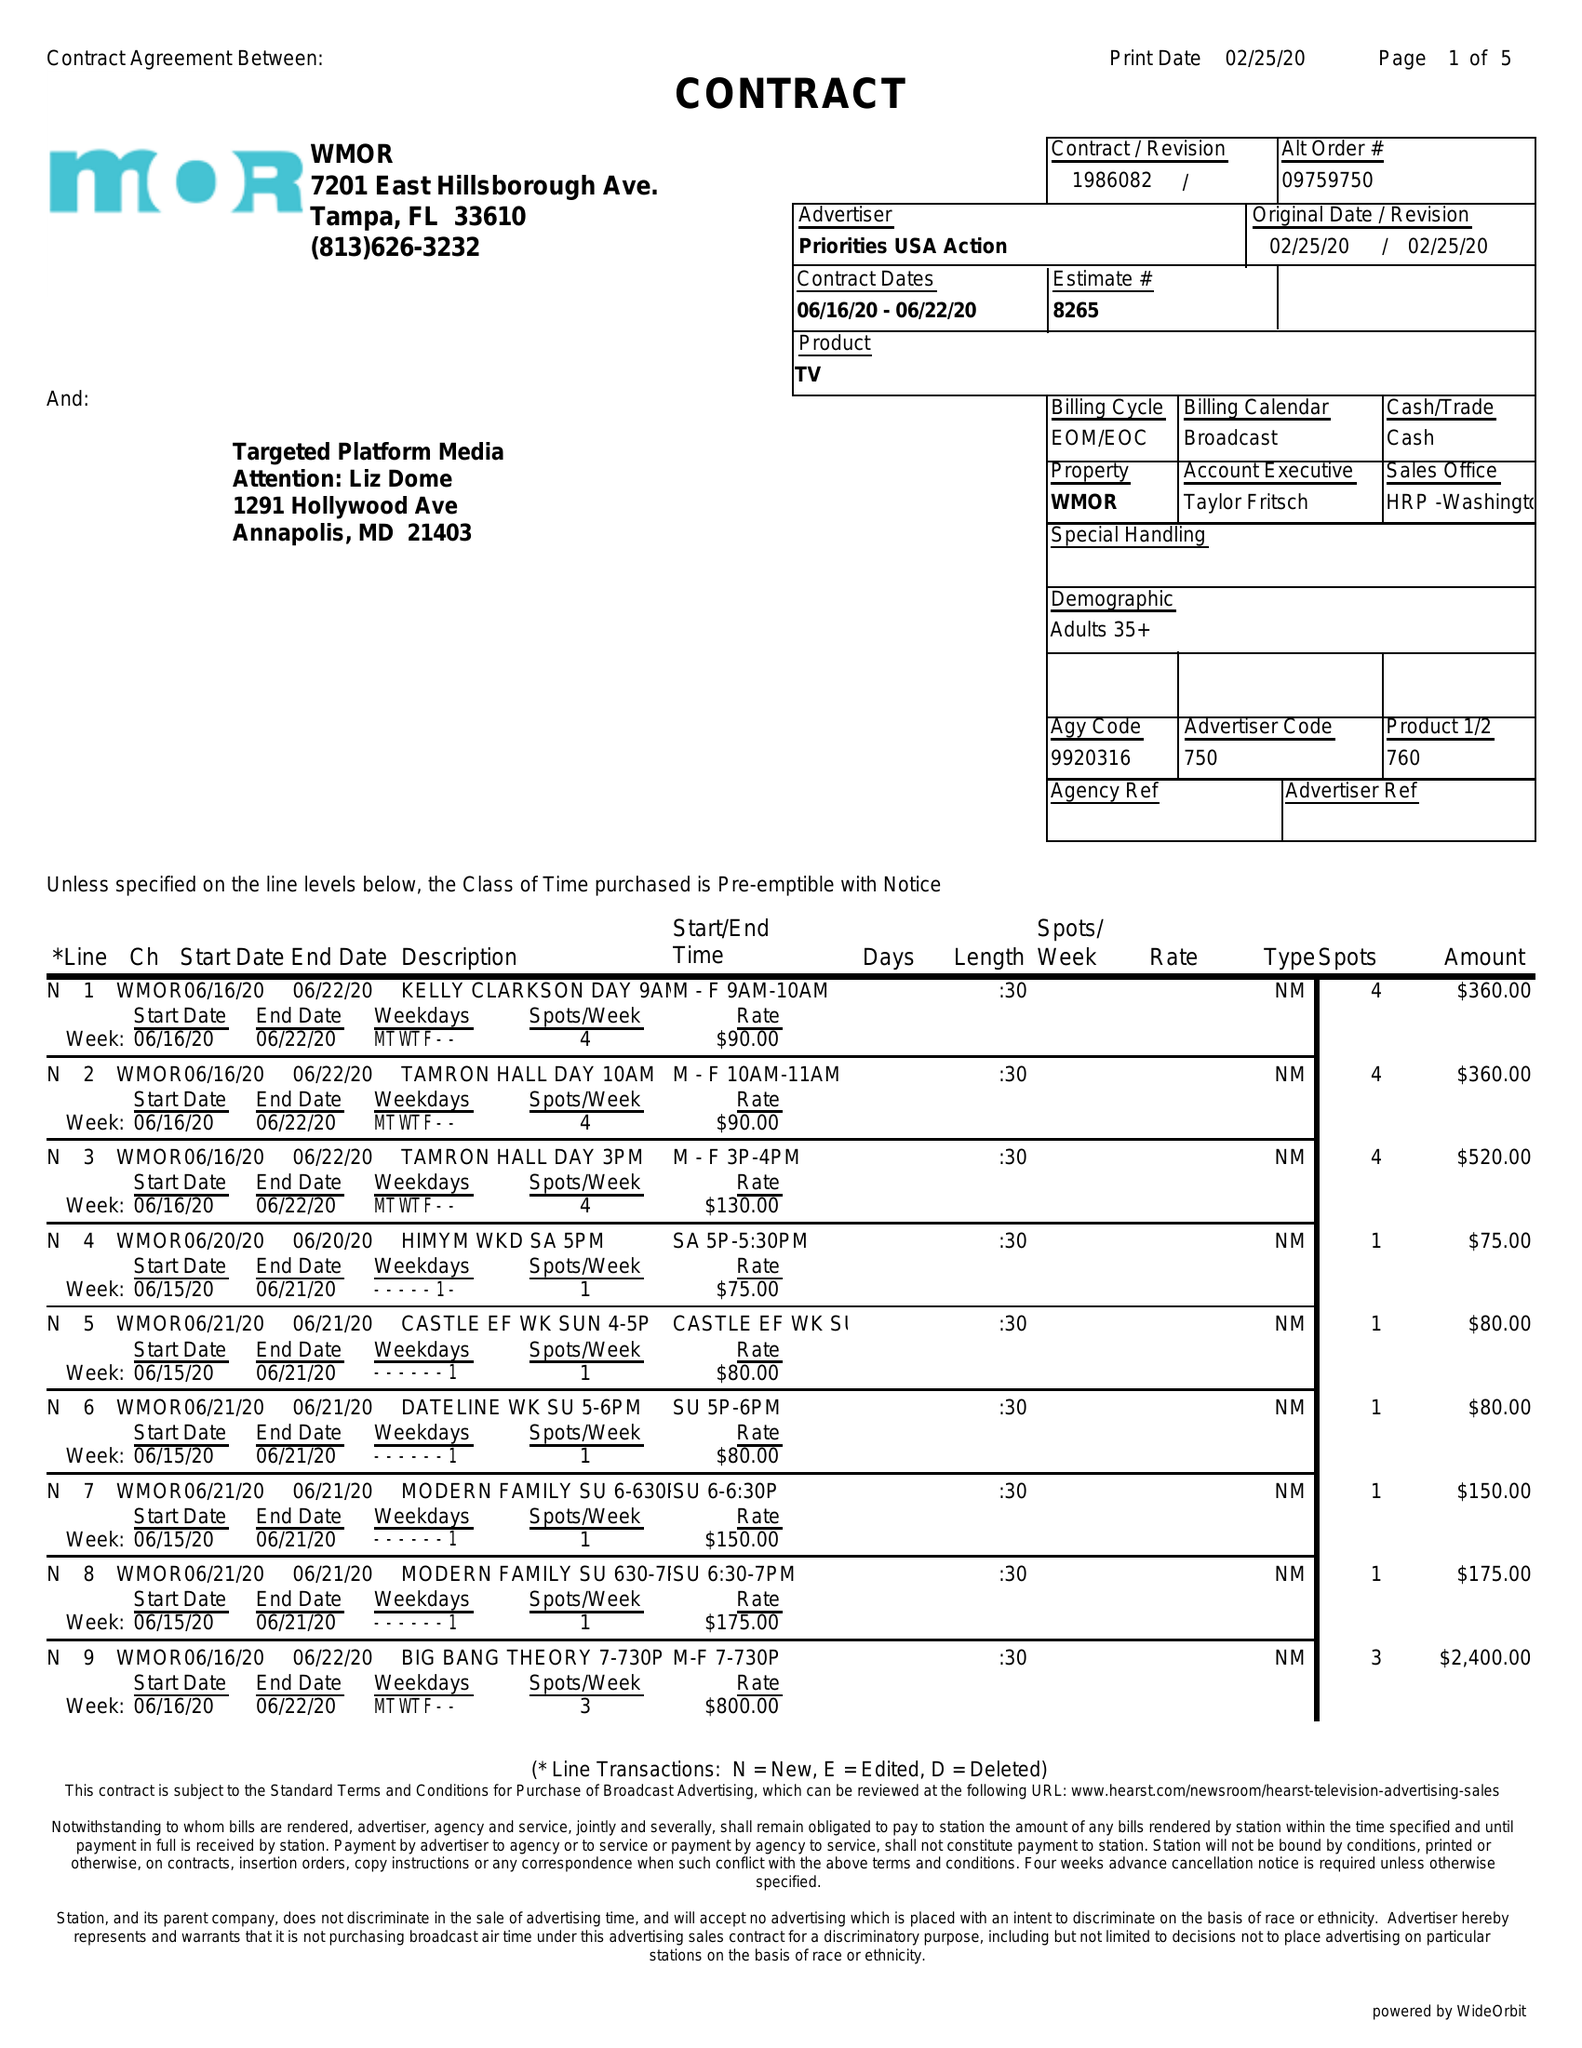What is the value for the flight_to?
Answer the question using a single word or phrase. 06/22/20 